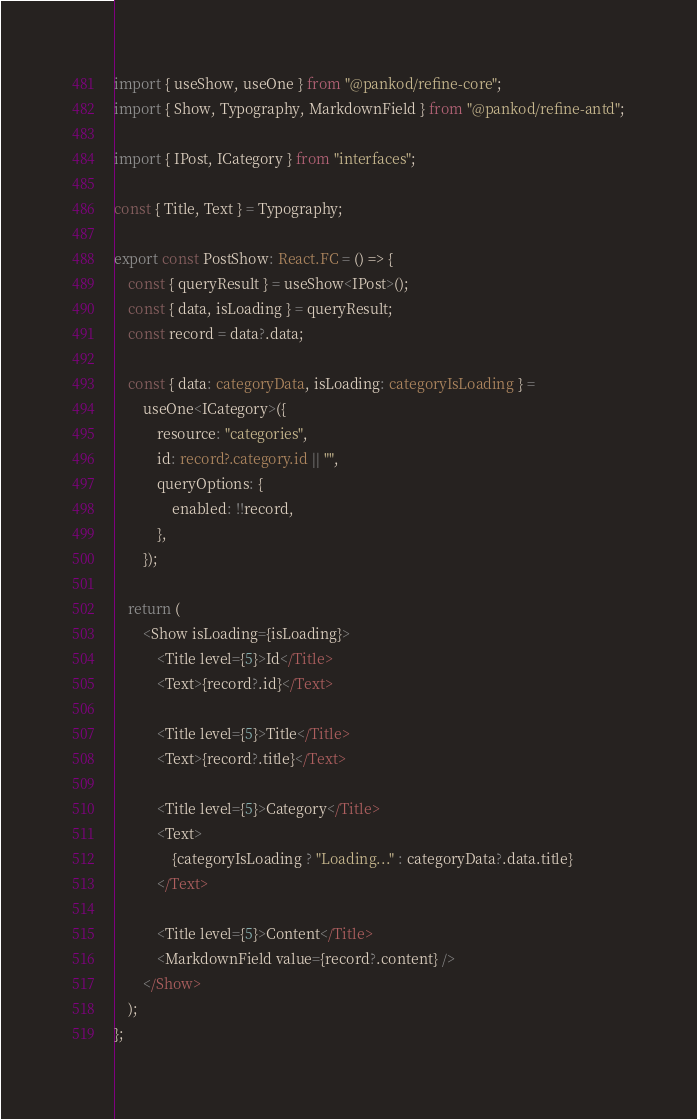Convert code to text. <code><loc_0><loc_0><loc_500><loc_500><_TypeScript_>import { useShow, useOne } from "@pankod/refine-core";
import { Show, Typography, MarkdownField } from "@pankod/refine-antd";

import { IPost, ICategory } from "interfaces";

const { Title, Text } = Typography;

export const PostShow: React.FC = () => {
    const { queryResult } = useShow<IPost>();
    const { data, isLoading } = queryResult;
    const record = data?.data;

    const { data: categoryData, isLoading: categoryIsLoading } =
        useOne<ICategory>({
            resource: "categories",
            id: record?.category.id || "",
            queryOptions: {
                enabled: !!record,
            },
        });

    return (
        <Show isLoading={isLoading}>
            <Title level={5}>Id</Title>
            <Text>{record?.id}</Text>

            <Title level={5}>Title</Title>
            <Text>{record?.title}</Text>

            <Title level={5}>Category</Title>
            <Text>
                {categoryIsLoading ? "Loading..." : categoryData?.data.title}
            </Text>

            <Title level={5}>Content</Title>
            <MarkdownField value={record?.content} />
        </Show>
    );
};
</code> 